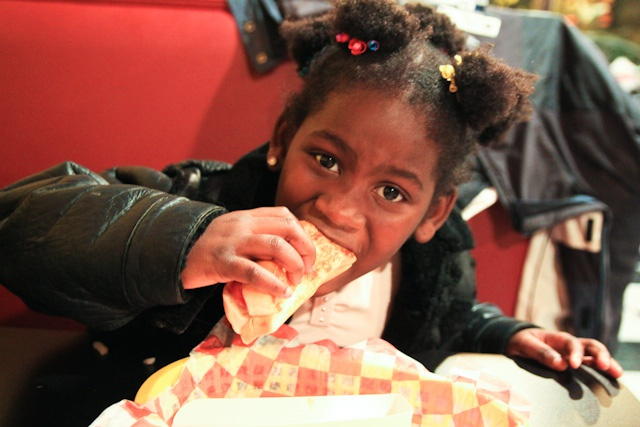Describe the objects in this image and their specific colors. I can see people in brown, black, and maroon tones, chair in brown, salmon, and red tones, and hot dog in brown, khaki, tan, lightyellow, and salmon tones in this image. 